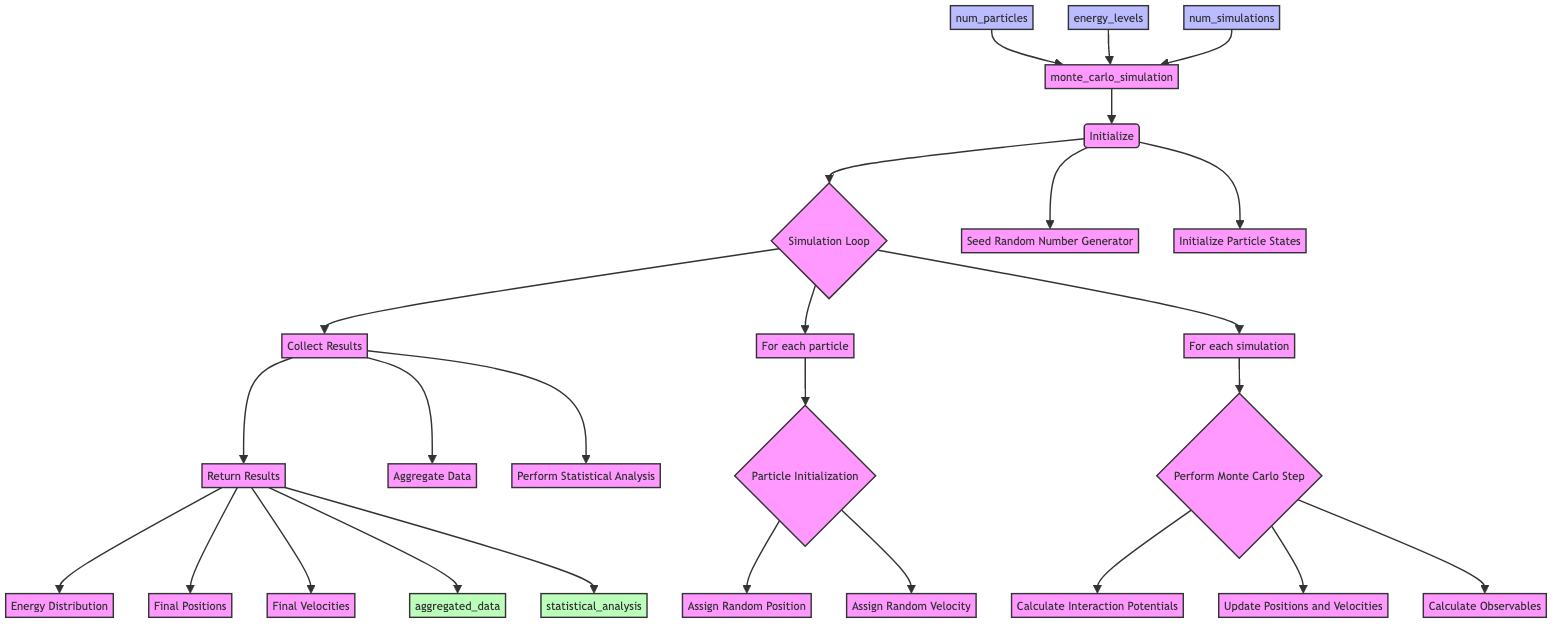what are the inputs of the function? The diagram shows three nodes connected to the function "monte_carlo_simulation," indicating the required inputs: num_particles, energy_levels, and num_simulations.
Answer: num_particles, energy_levels, num_simulations what is the first step in the simulation process? The diagram shows the first step of the function after initialization, which is the "Simulation Loop" represented by node C.
Answer: Simulation Loop how many tasks are in the "Initialize" step? The "Initialize" step has two tasks listed under it: "Seed Random Number Generator" and "Initialize Particle States." Therefore, the count is two.
Answer: 2 what is the final output of the function? The flowchart indicates that the final output of the function includes the nodes: "Energy Distribution," "Final Positions," and "Final Velocities," which are part of the "Return Results" step.
Answer: Energy Distribution, Final Positions, Final Velocities how many loops are present in the "Simulation Loop" step? In the "Simulation Loop" step, there are two identified loops: one for "For each particle" and another for "For each simulation." This totals to two loops.
Answer: 2 which step directly follows "Collect Results"? The diagram shows that after "Collect Results," the next step is "Return Results." This is indicated by a direct arrow from D to E in the flowchart.
Answer: Return Results what are the first two tasks performed in the "Initialize" step? According to the flowchart, the first two tasks listed under "Initialize" are "Seed Random Number Generator" and "Initialize Particle States."
Answer: Seed Random Number Generator, Initialize Particle States what happens after "Perform Monte Carlo Step"? The diagram indicates that after "Perform Monte Carlo Step," the next tasks are related to "Aggregate Data" and "Perform Statistical Analysis" under the "Collect Results" step.
Answer: Aggregate Data, Perform Statistical Analysis how is the random initialization of particles achieved? The initialization of particles involves two tasks: "Assign Random Position" and "Assign Random Velocity," as shown in the "Particle Initialization" step.
Answer: Assign Random Position, Assign Random Velocity 